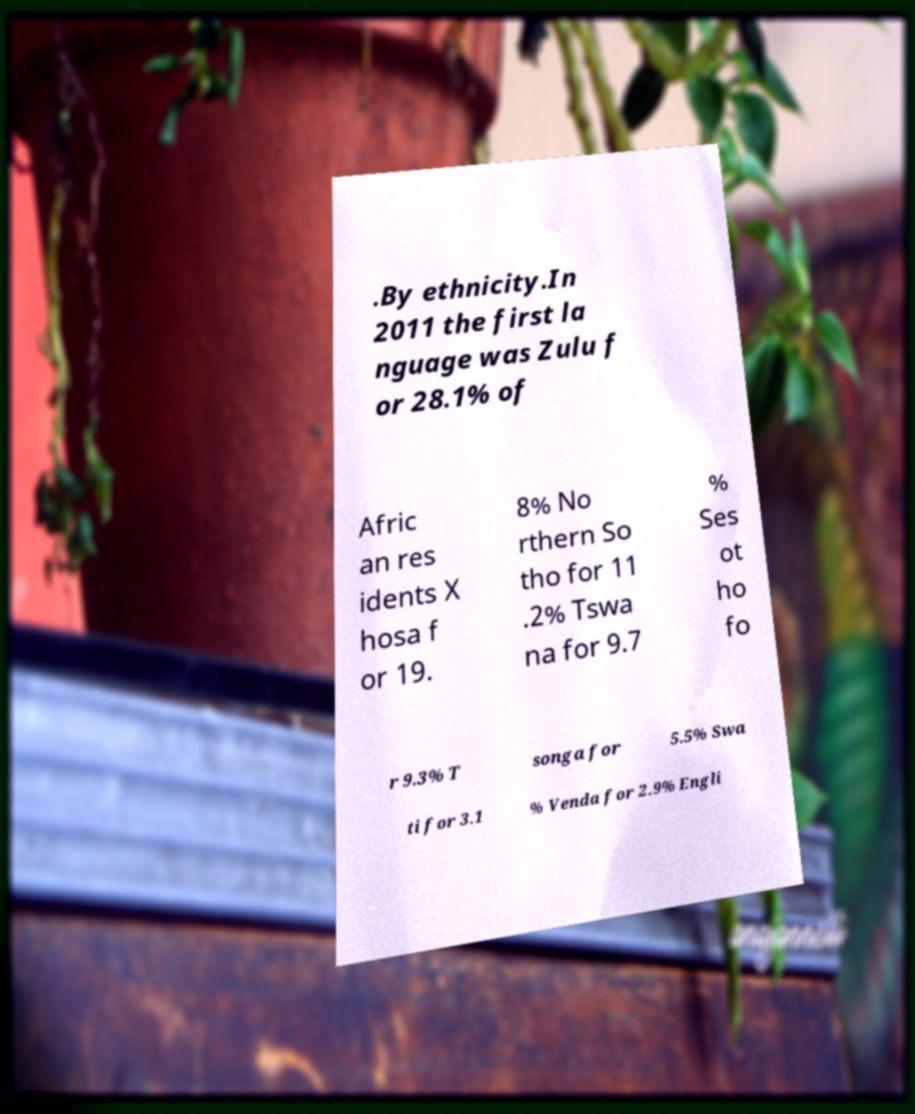Could you assist in decoding the text presented in this image and type it out clearly? .By ethnicity.In 2011 the first la nguage was Zulu f or 28.1% of Afric an res idents X hosa f or 19. 8% No rthern So tho for 11 .2% Tswa na for 9.7 % Ses ot ho fo r 9.3% T songa for 5.5% Swa ti for 3.1 % Venda for 2.9% Engli 